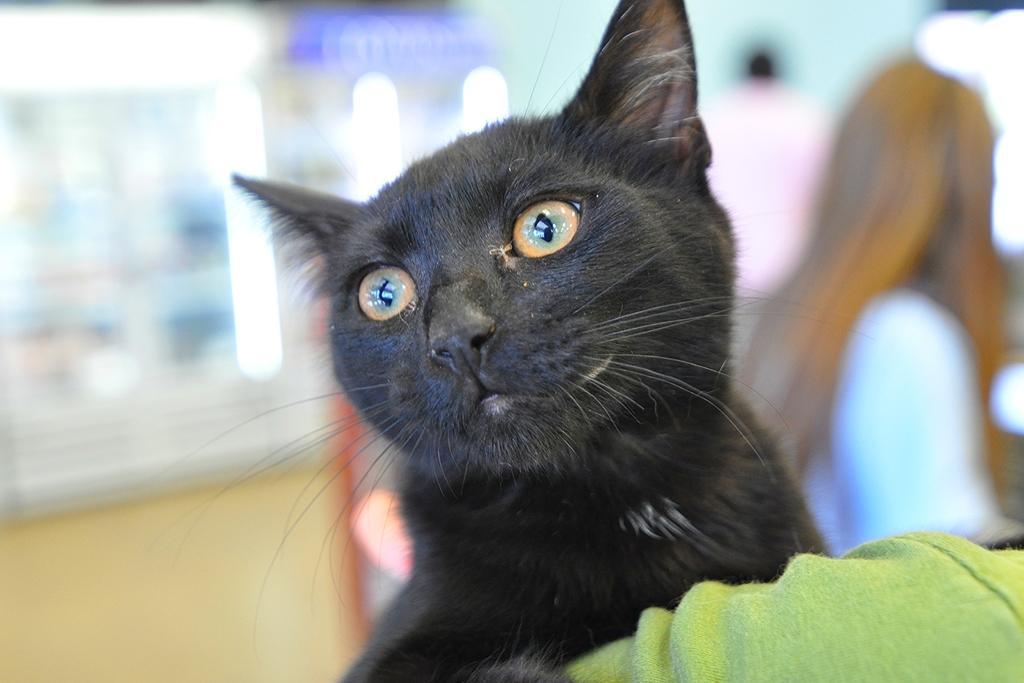How would you summarize this image in a sentence or two? In this image we can see a cat and a cloth. There is a blur background. 